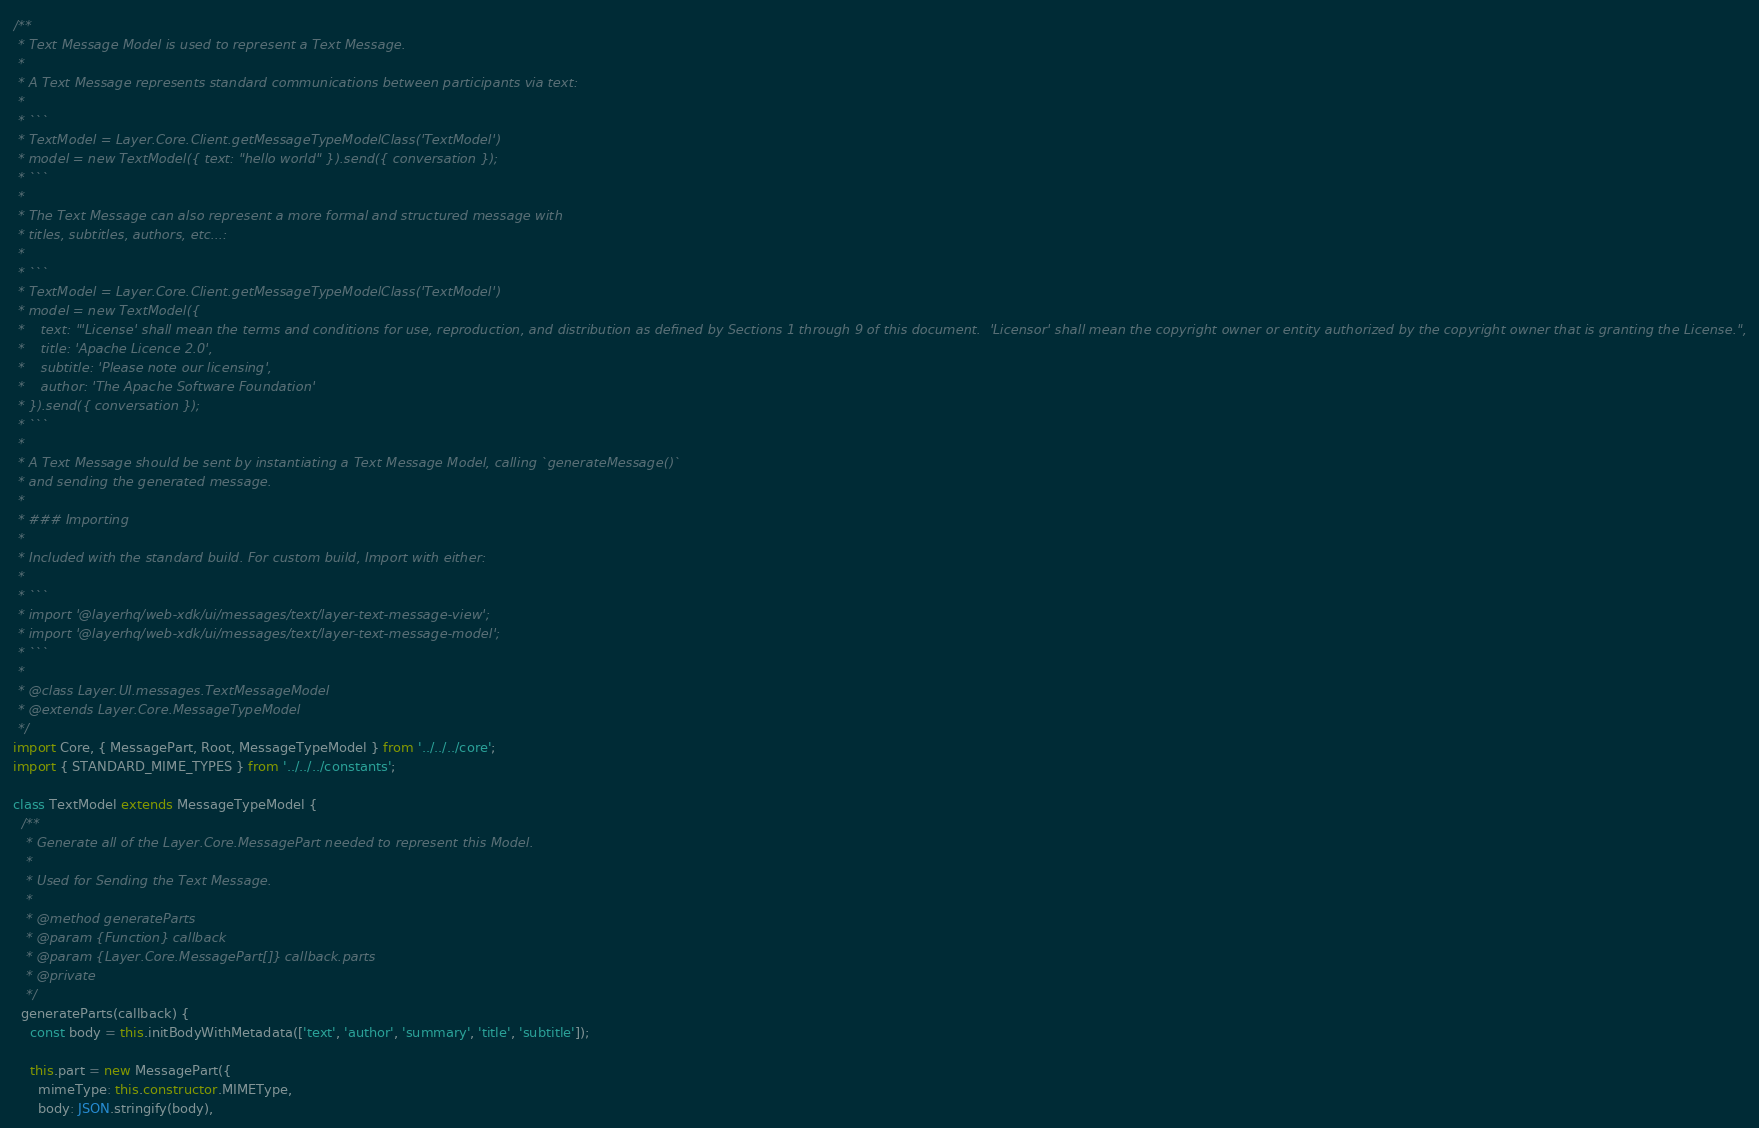<code> <loc_0><loc_0><loc_500><loc_500><_JavaScript_>/**
 * Text Message Model is used to represent a Text Message.
 *
 * A Text Message represents standard communications between participants via text:
 *
 * ```
 * TextModel = Layer.Core.Client.getMessageTypeModelClass('TextModel')
 * model = new TextModel({ text: "hello world" }).send({ conversation });
 * ```
 *
 * The Text Message can also represent a more formal and structured message with
 * titles, subtitles, authors, etc...:
 *
 * ```
 * TextModel = Layer.Core.Client.getMessageTypeModelClass('TextModel')
 * model = new TextModel({
 *    text: "'License' shall mean the terms and conditions for use, reproduction, and distribution as defined by Sections 1 through 9 of this document.  'Licensor' shall mean the copyright owner or entity authorized by the copyright owner that is granting the License.",
 *    title: 'Apache Licence 2.0',
 *    subtitle: 'Please note our licensing',
 *    author: 'The Apache Software Foundation'
 * }).send({ conversation });
 * ```
 *
 * A Text Message should be sent by instantiating a Text Message Model, calling `generateMessage()`
 * and sending the generated message.
 *
 * ### Importing
 *
 * Included with the standard build. For custom build, Import with either:
 *
 * ```
 * import '@layerhq/web-xdk/ui/messages/text/layer-text-message-view';
 * import '@layerhq/web-xdk/ui/messages/text/layer-text-message-model';
 * ```
 *
 * @class Layer.UI.messages.TextMessageModel
 * @extends Layer.Core.MessageTypeModel
 */
import Core, { MessagePart, Root, MessageTypeModel } from '../../../core';
import { STANDARD_MIME_TYPES } from '../../../constants';

class TextModel extends MessageTypeModel {
  /**
   * Generate all of the Layer.Core.MessagePart needed to represent this Model.
   *
   * Used for Sending the Text Message.
   *
   * @method generateParts
   * @param {Function} callback
   * @param {Layer.Core.MessagePart[]} callback.parts
   * @private
   */
  generateParts(callback) {
    const body = this.initBodyWithMetadata(['text', 'author', 'summary', 'title', 'subtitle']);

    this.part = new MessagePart({
      mimeType: this.constructor.MIMEType,
      body: JSON.stringify(body),</code> 